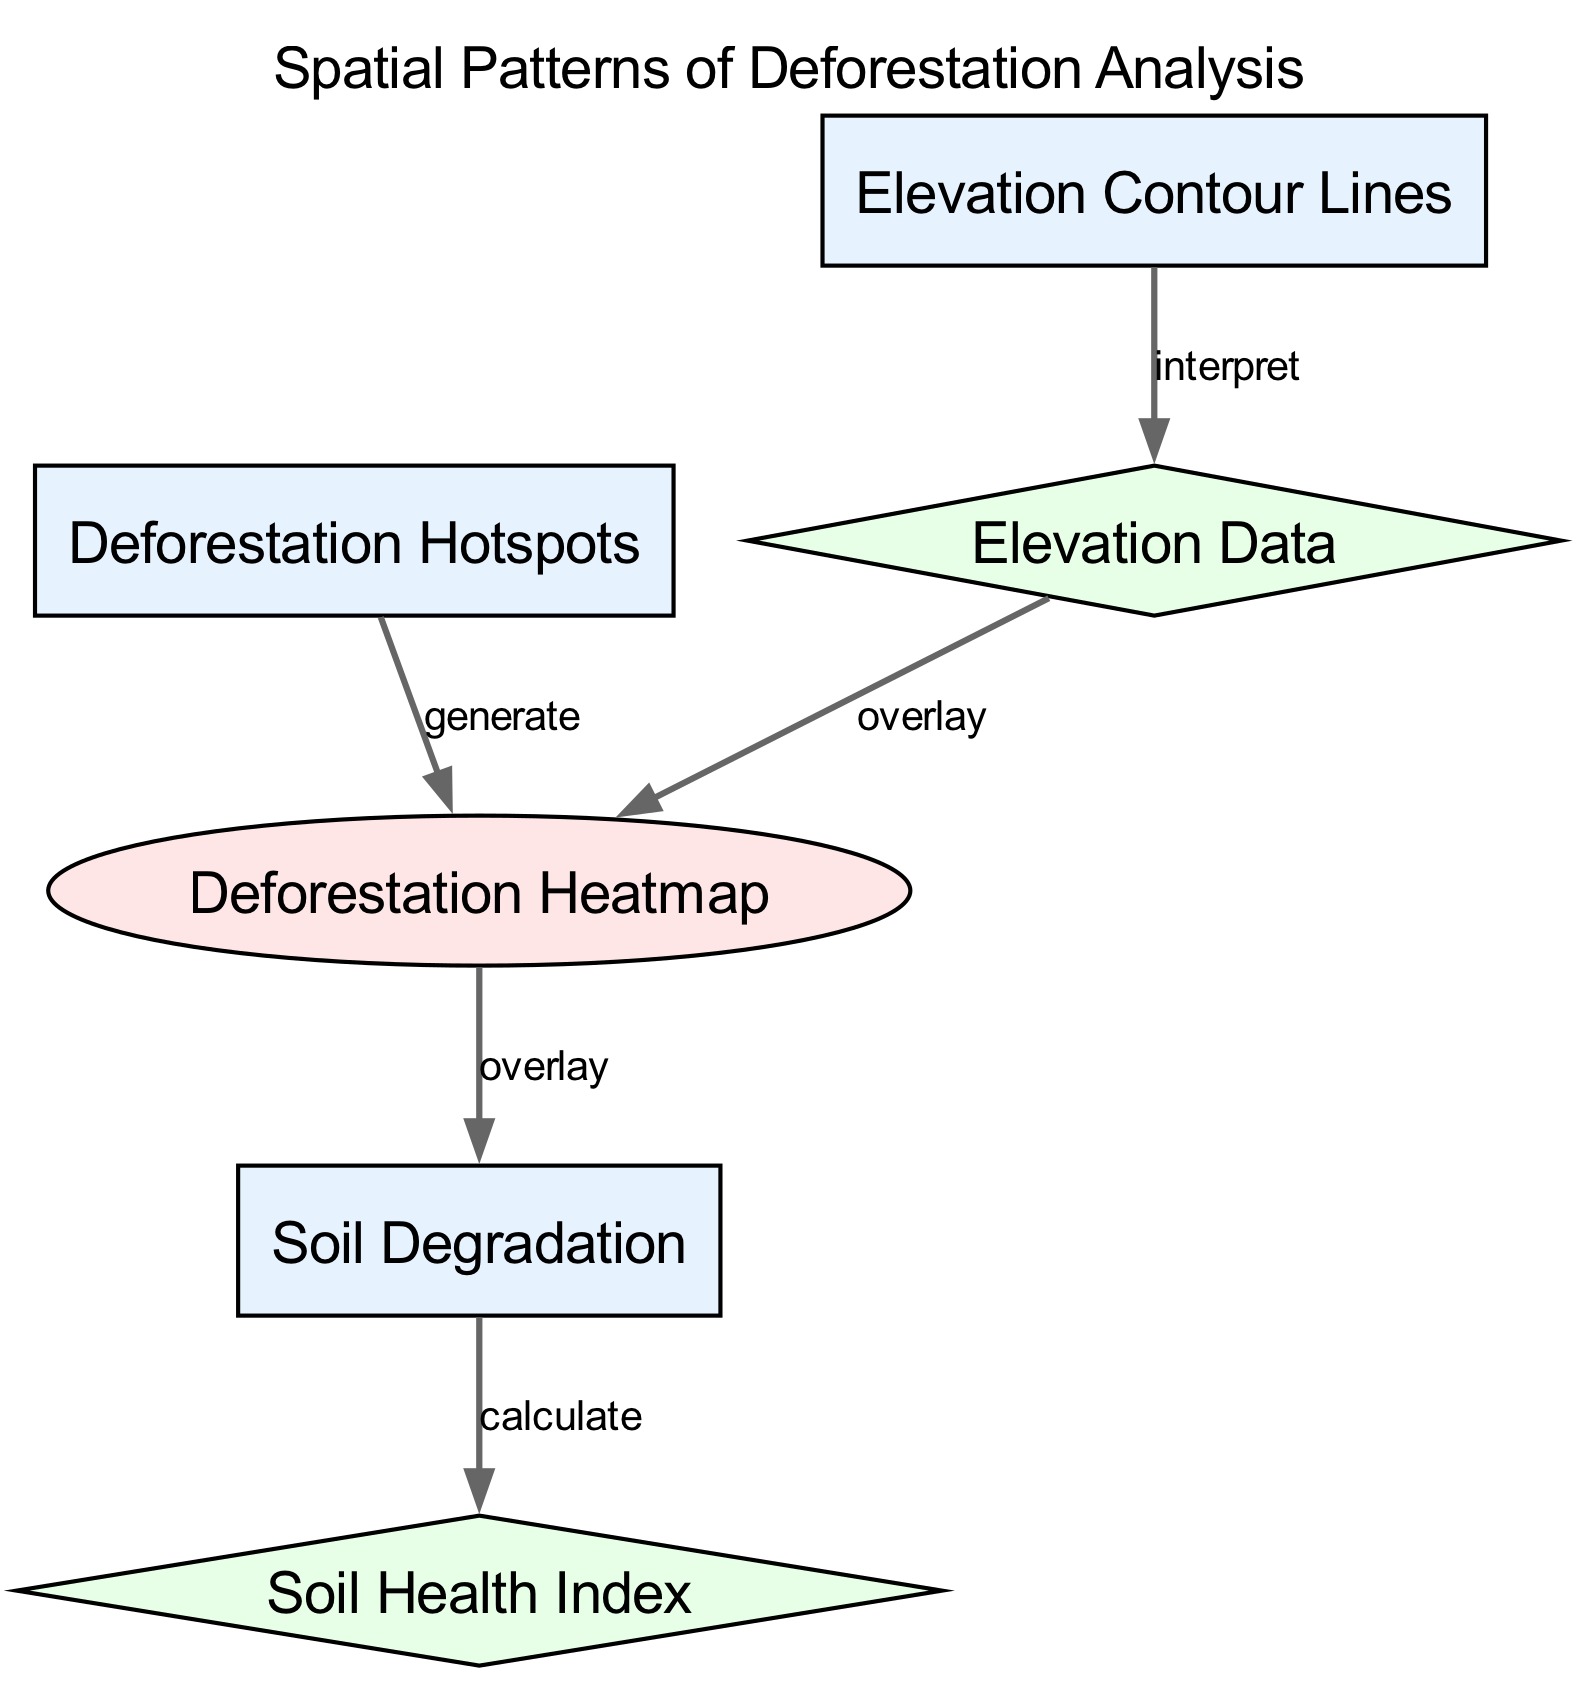What are the three main data layers in the diagram? The diagram includes three main data layers: Deforestation Hotspots, Soil Degradation, and Elevation Contour Lines.
Answer: Deforestation Hotspots, Soil Degradation, Elevation Contour Lines How many edges connect the nodes in the diagram? There are four edges connecting the nodes, as each edge represents a specific relationship between the data layers and visualizations.
Answer: Four What does the heatmap overlay represent? The heatmap overlay represents the correlation between deforestation hotspots and soil degradation, visualizing patterns of deforestation in relation to soil health.
Answer: Correlation between deforestation hotspots and soil degradation Which node is calculated from soil degradation? The node that is calculated from soil degradation is the Soil Health Index, which is derived by assessing the condition of the soil in relation to degradation.
Answer: Soil Health Index Explain the relationship between elevation data and the heatmap. The relationship indicates that elevation data is used to overlay the heatmap, enhancing the spatial understanding of deforestation hotspots in relation to varying elevations. This means that as the elevation data is interpreted, it aids in visualizing where deforestation occurs concerning different elevation levels.
Answer: Elevation data overlays the heatmap What is the purpose of contour lines in this diagram? The contour lines indicate different elevation levels, providing essential geographical context that helps analyze how elevation may influence soil degradation and deforestation hotspots.
Answer: Indicate elevation levels Which specific layer provides the data for interpreting the elevation contour lines? The elevation contour lines are interpreted using Elevation Data, which is associated with the actual measurements of elevation in the specified area.
Answer: Elevation Data How is soil degradation visually represented in the diagram? Soil degradation is visually represented through the heatmap that overlays it, showing areas where degradation occurs in relation to deforestation hotspots.
Answer: Through the heatmap overlay What is the label of the visualization type in the diagram? The label of the visualization type in the diagram is "Deforestation Heatmap," which visually represents the intensity of deforestation in various regions.
Answer: Deforestation Heatmap 